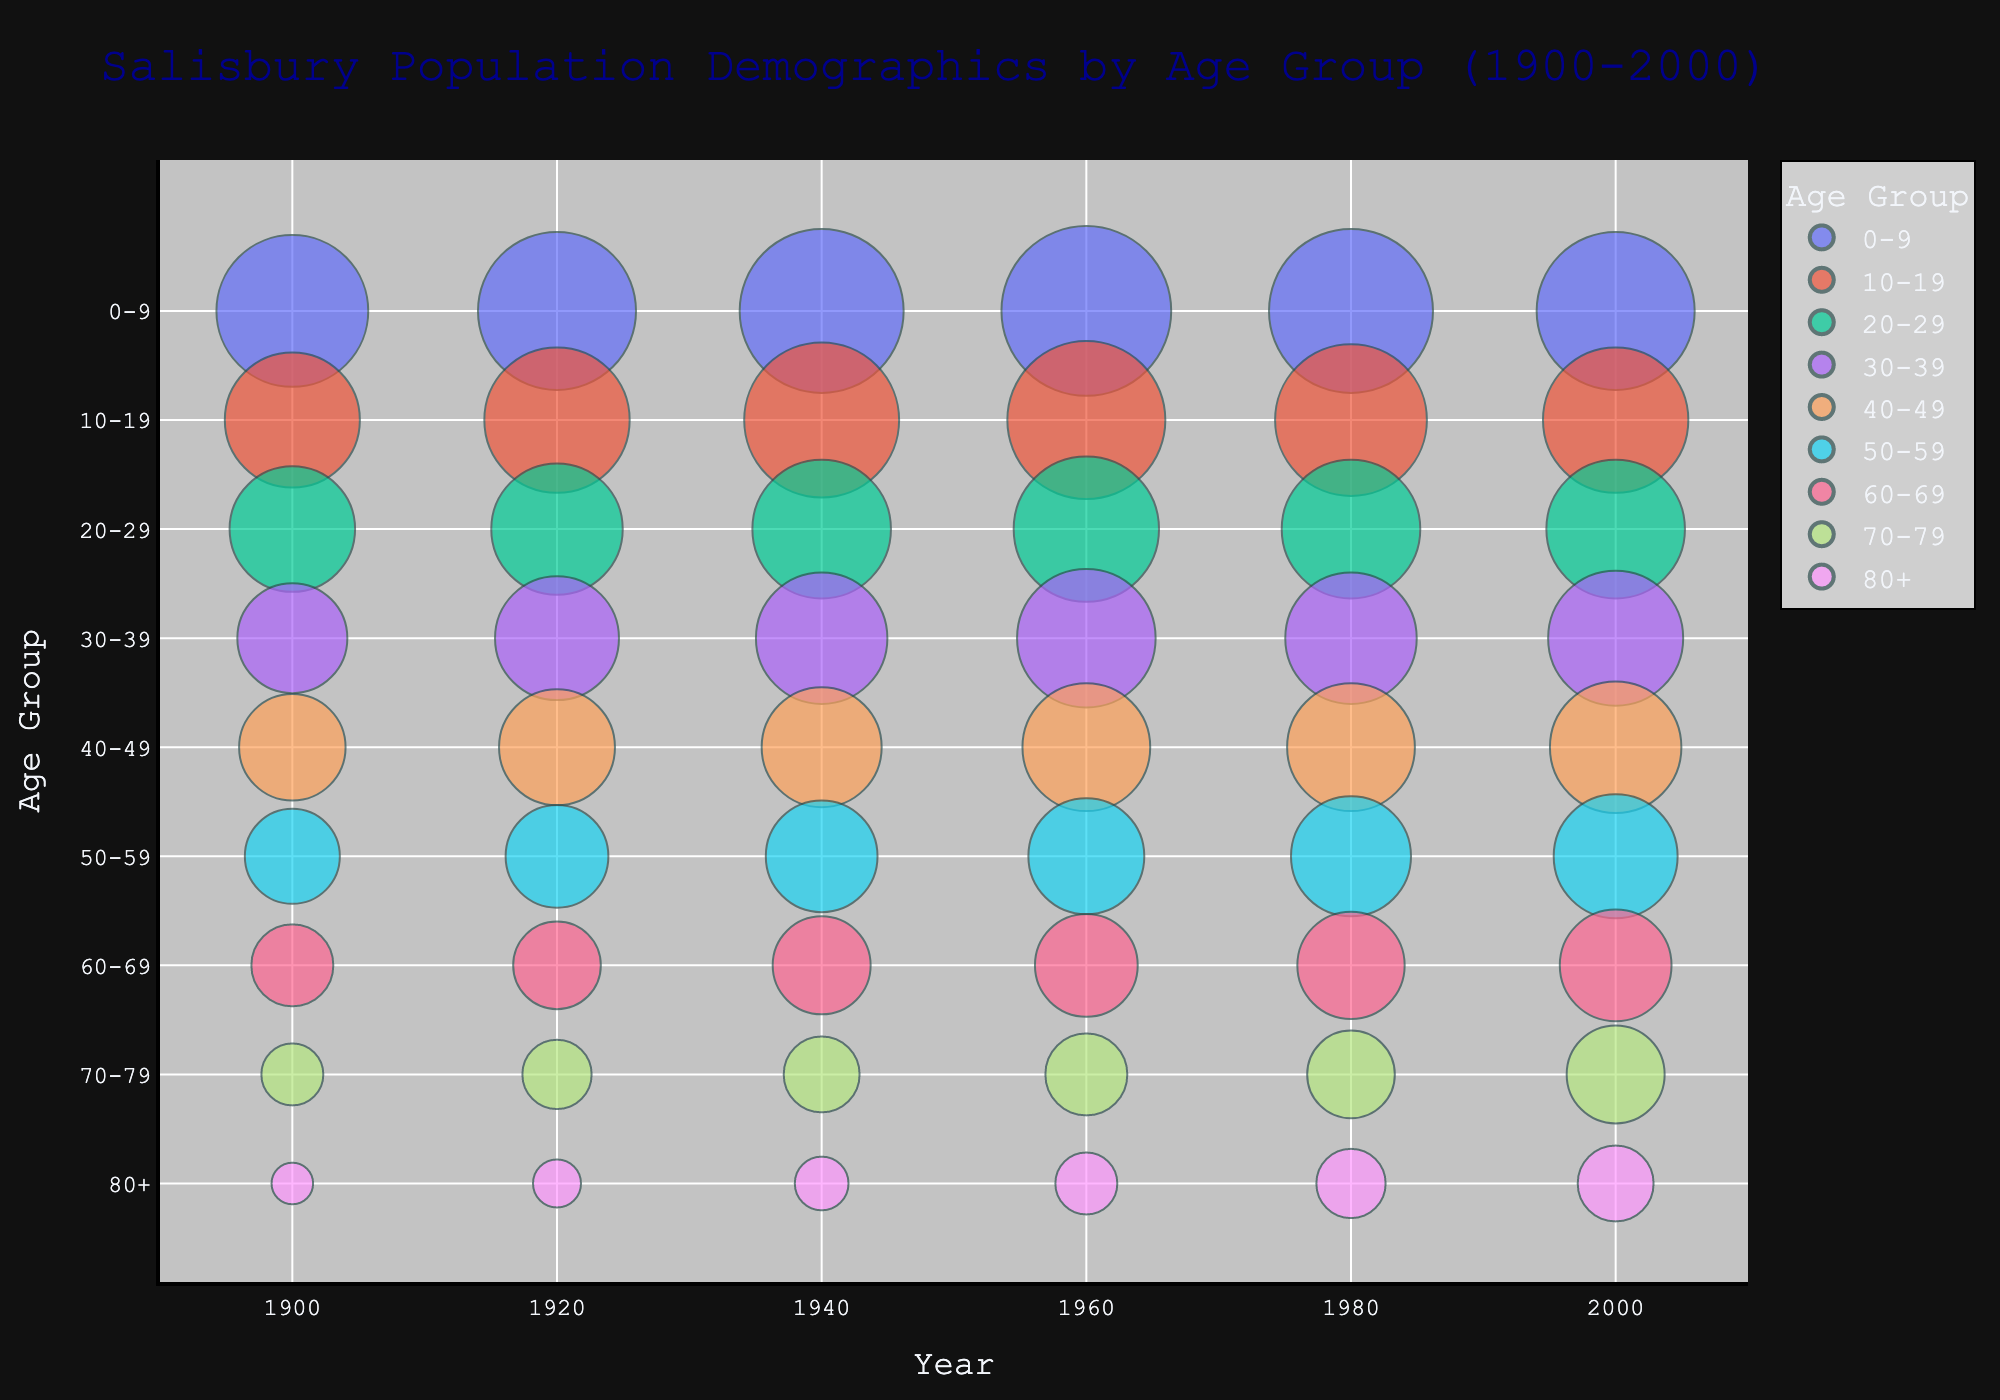what is the title of the chart? The title is positioned at the top center of the chart and typically provides a brief description of the visualized data.
Answer: Salisbury Population Demographics by Age Group (1900-2000) what age group had the largest population in 1940? The size of each bubble in a bubble chart represents the population. By comparing the bubbles for the year 1940, the largest bubble represents the age group 0-9.
Answer: 0-9 which decade saw the biggest increase in the 60-69 age group's population? Examine the population trends for the 60-69 age group across each decade. Calculate the differences between contiguous decades and identify which has the greatest increase. The population increased from 350 (1920) to 500 (1940), which is the largest increase.
Answer: 1920 to 1940 how did the population of the 80+ age group change from 1900 to 2000? Look at the bubbles corresponding to the 80+ age group for the years 1900 and 2000. Verify their sizes: 90 in 1900 and 300 in 2000. The population increased by 210.
Answer: Increased by 210 compare the population of age group 20-29 in 1960 and 1980. which year had a higher population? Compare the sizes of the bubbles for the age group 20-29 in the years 1960 and 1980. Both bubbles represent a population of 1000, meaning the population is the same for both years.
Answer: Same which age group had the smallest population in 1900 and what was it? Identify the smallest bubble for the year 1900, which represents the age group 80+, with a population of 90.
Answer: 80+, 90 what was the total population for all age groups in 1940? Sum the populations of all age groups for the year 1940: 1400, 1250, 1000, 900, 750, 650, 500, 300, 150. The total is 7900.
Answer: 7900 did the population of the 10-19 age group increase or decrease from 1960 to 2000? By comparing the bubble sizes for the 10-19 age group in 1960 (1300) and 2000 (1100), we see that the population decreased.
Answer: Decreased is the population trend for the 0-9 age group always increasing, decreasing, or fluctuating over the decades? By tracking the changes in the bubble sizes for the 0-9 age group across all years (1200, 1300, 1400, 1500, 1400, 1300), the population increases from 1900 to 1960, then fluctuates with a decrease from 1960 to 2000.
Answer: Fluctuating which age group showed the most consistent population increase across all decades? By examining the population data for each age group over all decades, the age group 80+ consistently shows an increase: (90, 120, 150, 200, 250, 300).
Answer: 80+ 